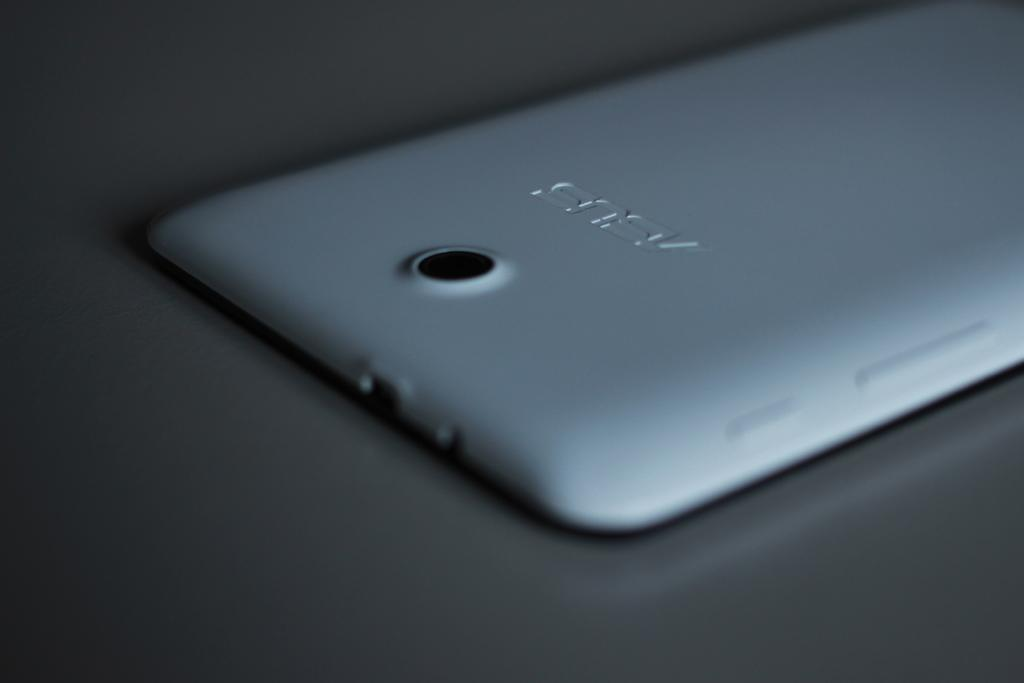<image>
Give a short and clear explanation of the subsequent image. The camera on the reverse of an Asus tablet is seen close up. 